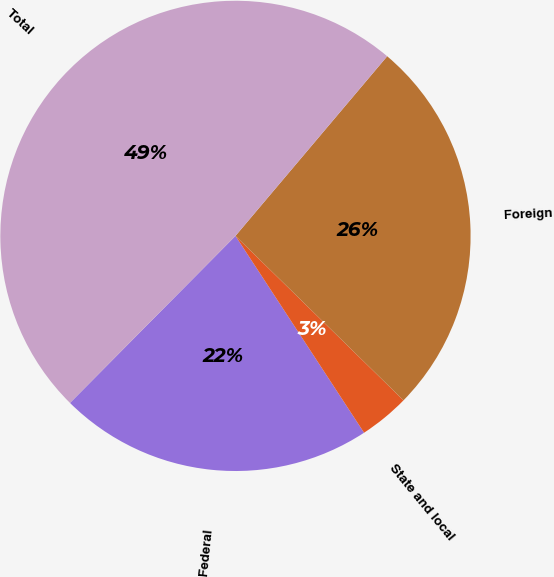Convert chart to OTSL. <chart><loc_0><loc_0><loc_500><loc_500><pie_chart><fcel>Federal<fcel>State and local<fcel>Foreign<fcel>Total<nl><fcel>21.64%<fcel>3.46%<fcel>26.17%<fcel>48.74%<nl></chart> 